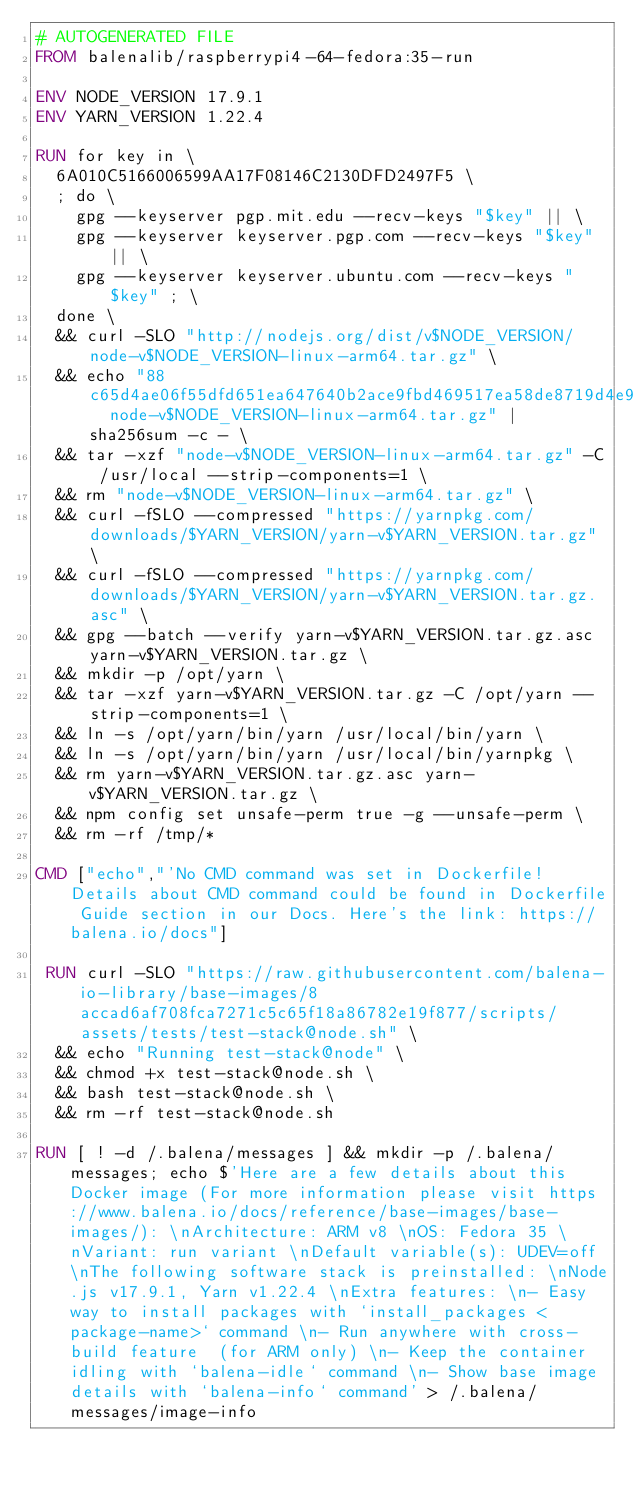Convert code to text. <code><loc_0><loc_0><loc_500><loc_500><_Dockerfile_># AUTOGENERATED FILE
FROM balenalib/raspberrypi4-64-fedora:35-run

ENV NODE_VERSION 17.9.1
ENV YARN_VERSION 1.22.4

RUN for key in \
	6A010C5166006599AA17F08146C2130DFD2497F5 \
	; do \
		gpg --keyserver pgp.mit.edu --recv-keys "$key" || \
		gpg --keyserver keyserver.pgp.com --recv-keys "$key" || \
		gpg --keyserver keyserver.ubuntu.com --recv-keys "$key" ; \
	done \
	&& curl -SLO "http://nodejs.org/dist/v$NODE_VERSION/node-v$NODE_VERSION-linux-arm64.tar.gz" \
	&& echo "88c65d4ae06f55dfd651ea647640b2ace9fbd469517ea58de8719d4e95618955  node-v$NODE_VERSION-linux-arm64.tar.gz" | sha256sum -c - \
	&& tar -xzf "node-v$NODE_VERSION-linux-arm64.tar.gz" -C /usr/local --strip-components=1 \
	&& rm "node-v$NODE_VERSION-linux-arm64.tar.gz" \
	&& curl -fSLO --compressed "https://yarnpkg.com/downloads/$YARN_VERSION/yarn-v$YARN_VERSION.tar.gz" \
	&& curl -fSLO --compressed "https://yarnpkg.com/downloads/$YARN_VERSION/yarn-v$YARN_VERSION.tar.gz.asc" \
	&& gpg --batch --verify yarn-v$YARN_VERSION.tar.gz.asc yarn-v$YARN_VERSION.tar.gz \
	&& mkdir -p /opt/yarn \
	&& tar -xzf yarn-v$YARN_VERSION.tar.gz -C /opt/yarn --strip-components=1 \
	&& ln -s /opt/yarn/bin/yarn /usr/local/bin/yarn \
	&& ln -s /opt/yarn/bin/yarn /usr/local/bin/yarnpkg \
	&& rm yarn-v$YARN_VERSION.tar.gz.asc yarn-v$YARN_VERSION.tar.gz \
	&& npm config set unsafe-perm true -g --unsafe-perm \
	&& rm -rf /tmp/*

CMD ["echo","'No CMD command was set in Dockerfile! Details about CMD command could be found in Dockerfile Guide section in our Docs. Here's the link: https://balena.io/docs"]

 RUN curl -SLO "https://raw.githubusercontent.com/balena-io-library/base-images/8accad6af708fca7271c5c65f18a86782e19f877/scripts/assets/tests/test-stack@node.sh" \
  && echo "Running test-stack@node" \
  && chmod +x test-stack@node.sh \
  && bash test-stack@node.sh \
  && rm -rf test-stack@node.sh 

RUN [ ! -d /.balena/messages ] && mkdir -p /.balena/messages; echo $'Here are a few details about this Docker image (For more information please visit https://www.balena.io/docs/reference/base-images/base-images/): \nArchitecture: ARM v8 \nOS: Fedora 35 \nVariant: run variant \nDefault variable(s): UDEV=off \nThe following software stack is preinstalled: \nNode.js v17.9.1, Yarn v1.22.4 \nExtra features: \n- Easy way to install packages with `install_packages <package-name>` command \n- Run anywhere with cross-build feature  (for ARM only) \n- Keep the container idling with `balena-idle` command \n- Show base image details with `balena-info` command' > /.balena/messages/image-info</code> 